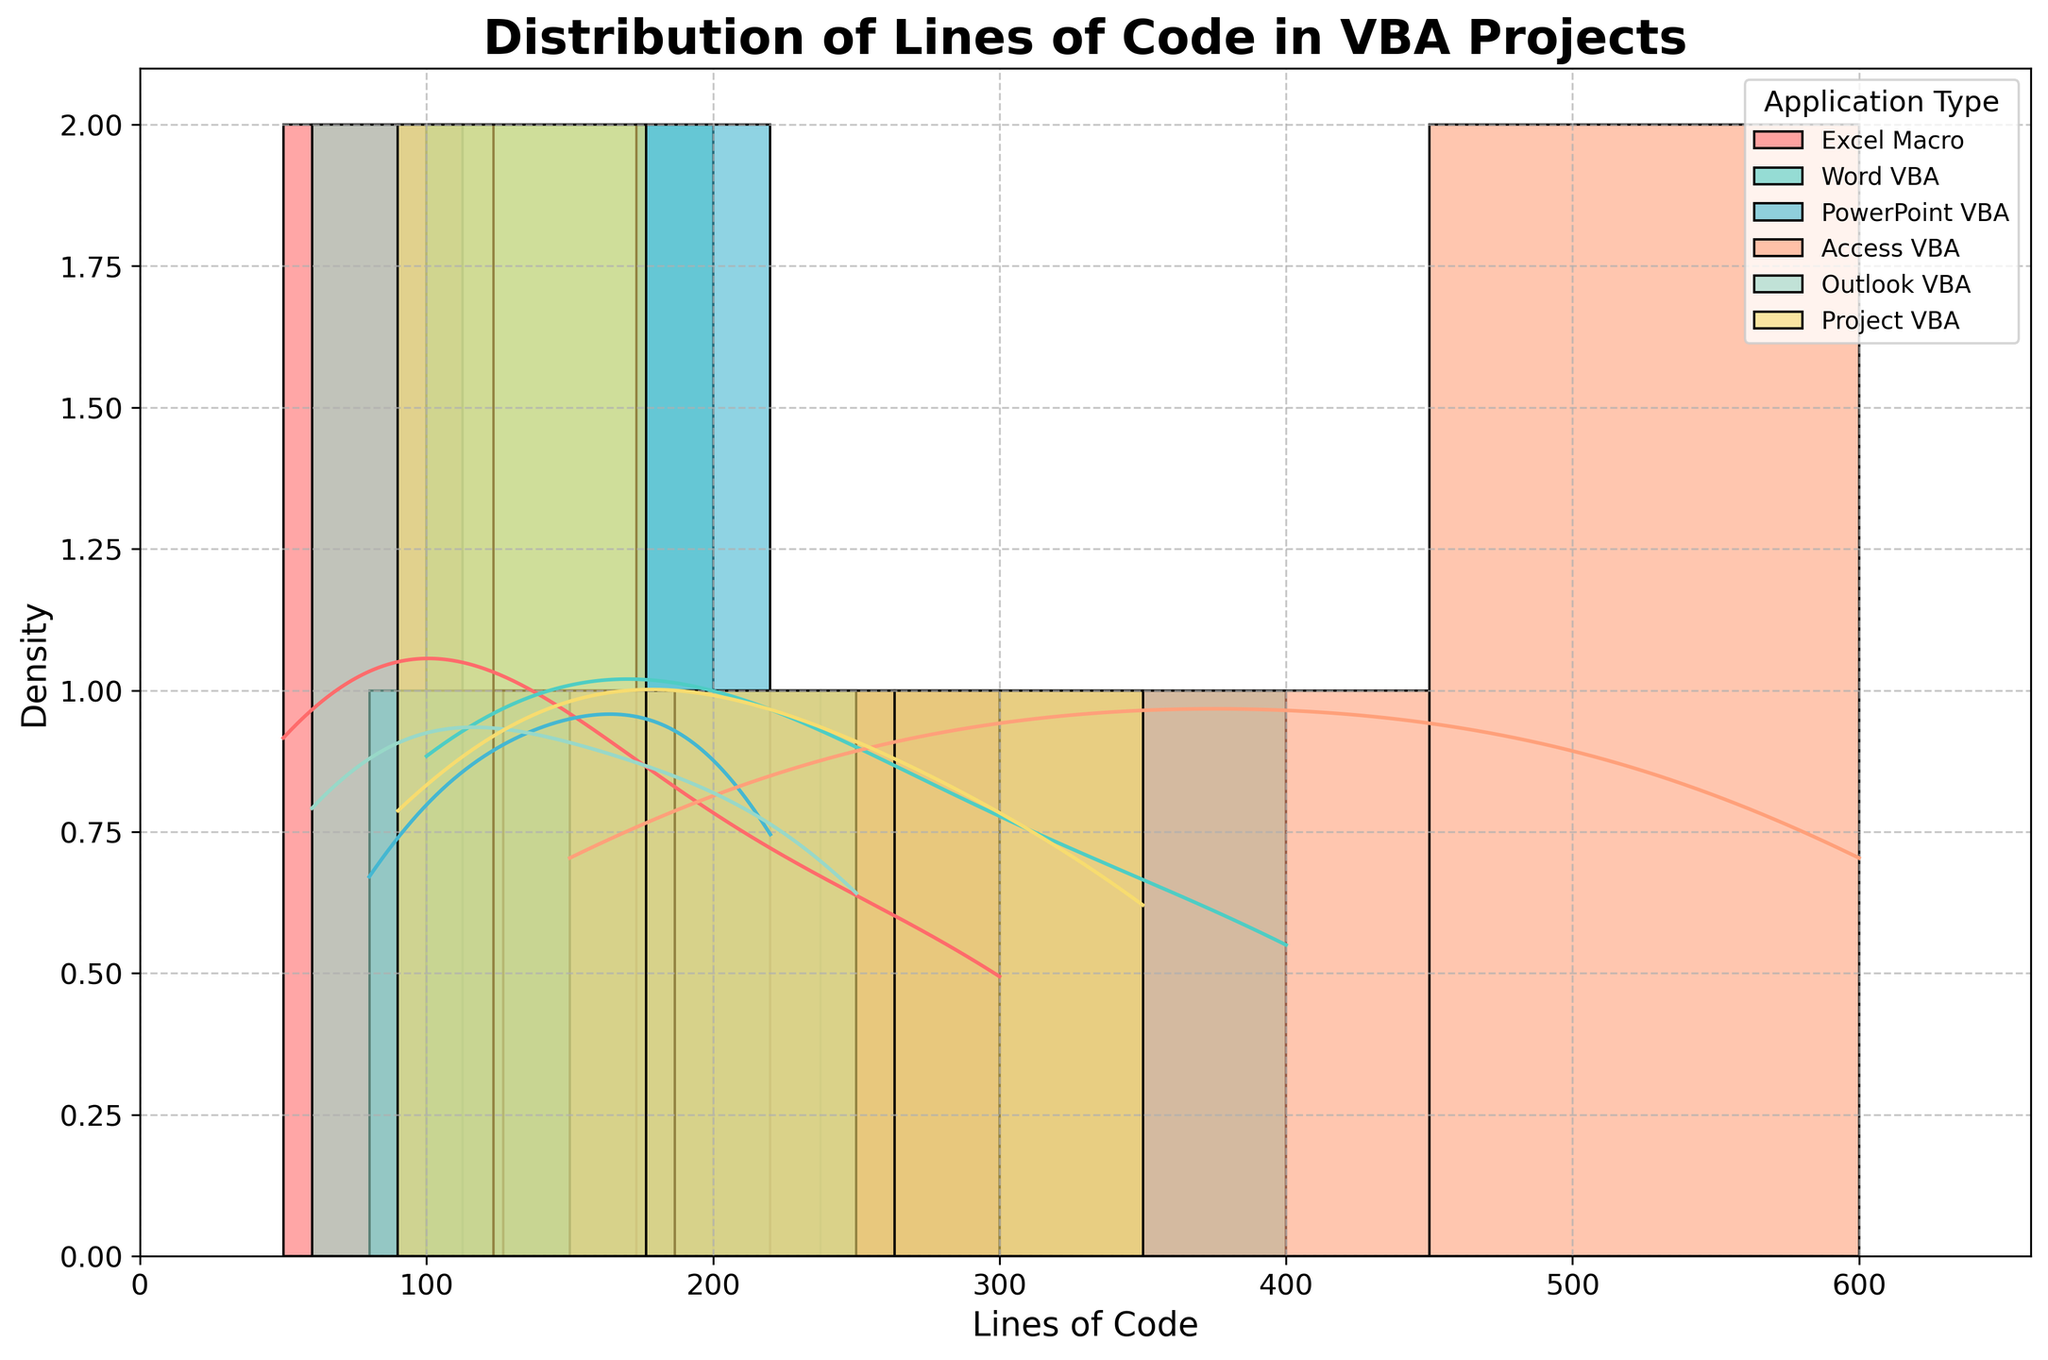What is the title of the graph? The title is located at the top of the figure, displayed in a bold font. The title summarizes the contents and purpose of the graph.
Answer: Distribution of Lines of Code in VBA Projects What are the maximum and minimum values of Lines of Code on the x-axis? By examining the x-axis, you can see the range of the lines of code values. The minimum value typically starts from 0 or slightly above it, and the maximum value will be extended slightly beyond the highest data point for better visualization.
Answer: 0 and around 660 Which application type has the highest density peak? Each KDE curve represents an application type, the highest density peak can be identified by finding the most elevated point on these curves.
Answer: Excel Macro Are there more lines of code in Access VBA projects compared to Outlook VBA projects? To compare the lines of code for these two application types, observe the distribution shifts and central tendencies of each KDE curve. Access VBA has higher density on higher lines of code values compared to Outlook VBA.
Answer: Yes What is the color representing PowerPoint VBA? Different colors are assigned to each application type. The color for PowerPoint VBA can be identified by examining the legend.
Answer: Light Blue Which application type shows the widest spread in the distribution of lines of code? The spread can be evaluated by looking at the width of the histogram bars and the KDE curve of each application type. The wider the spread of the curve, the larger the variability in lines of code.
Answer: Access VBA What is the main distinction between the lines of code in Word VBA and PowerPoint VBA? Compare the KDE curves of Word VBA and PowerPoint VBA by noting their peaks and spreads. Identify where the distributions overlap and where they diverge.
Answer: Word VBA tends to have higher peaks and values than PowerPoint VBA Does any application type show a bimodal distribution? Look for KDE curves that have two distinct peaks which indicate a bimodal distribution. This means that there are two different common values.
Answer: No application is clearly bimodal Which application type is most likely to have projects with fewer than 100 lines of code? Identify the application types whose KDE curves have significant density below 100 lines of code.
Answer: Outlook VBA How does the density curve help in understanding the distribution of lines of code? The KDE (density curve) smooths out the histogram and helps understand the underlying distribution by showing where the values are more concentrated. For example, it shows the mode and potential skew.
Answer: The density curve shows the concentration and spread of data, making the distribution's shape (e.g., peak, symmetry) more visible 